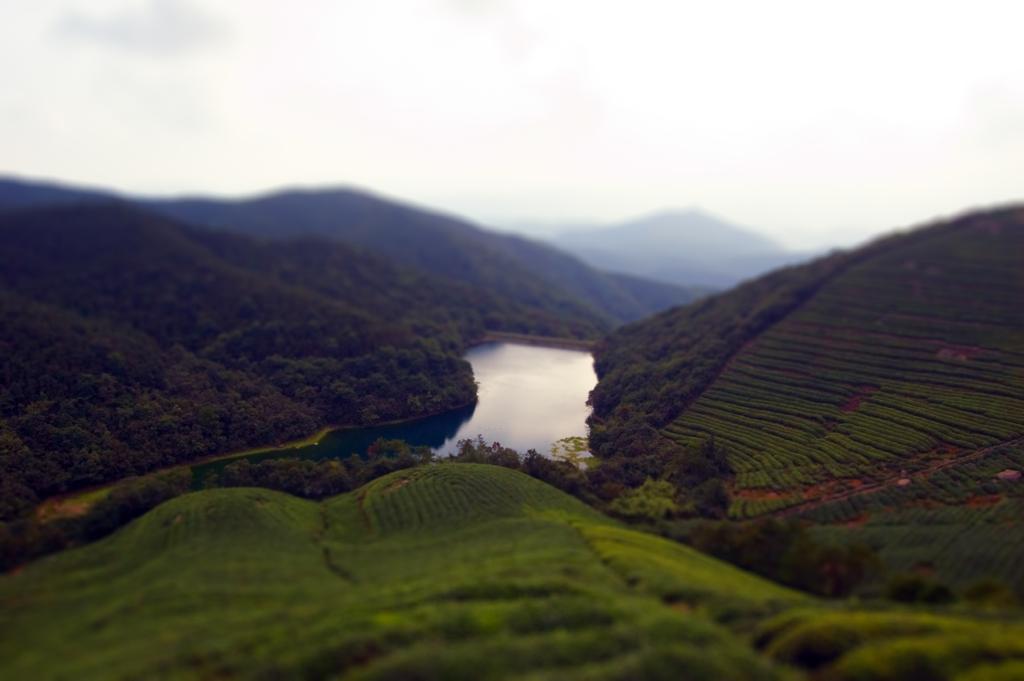Could you give a brief overview of what you see in this image? In this image we can see water. Also there are trees. In the background there are hills and there is sky with clouds. 